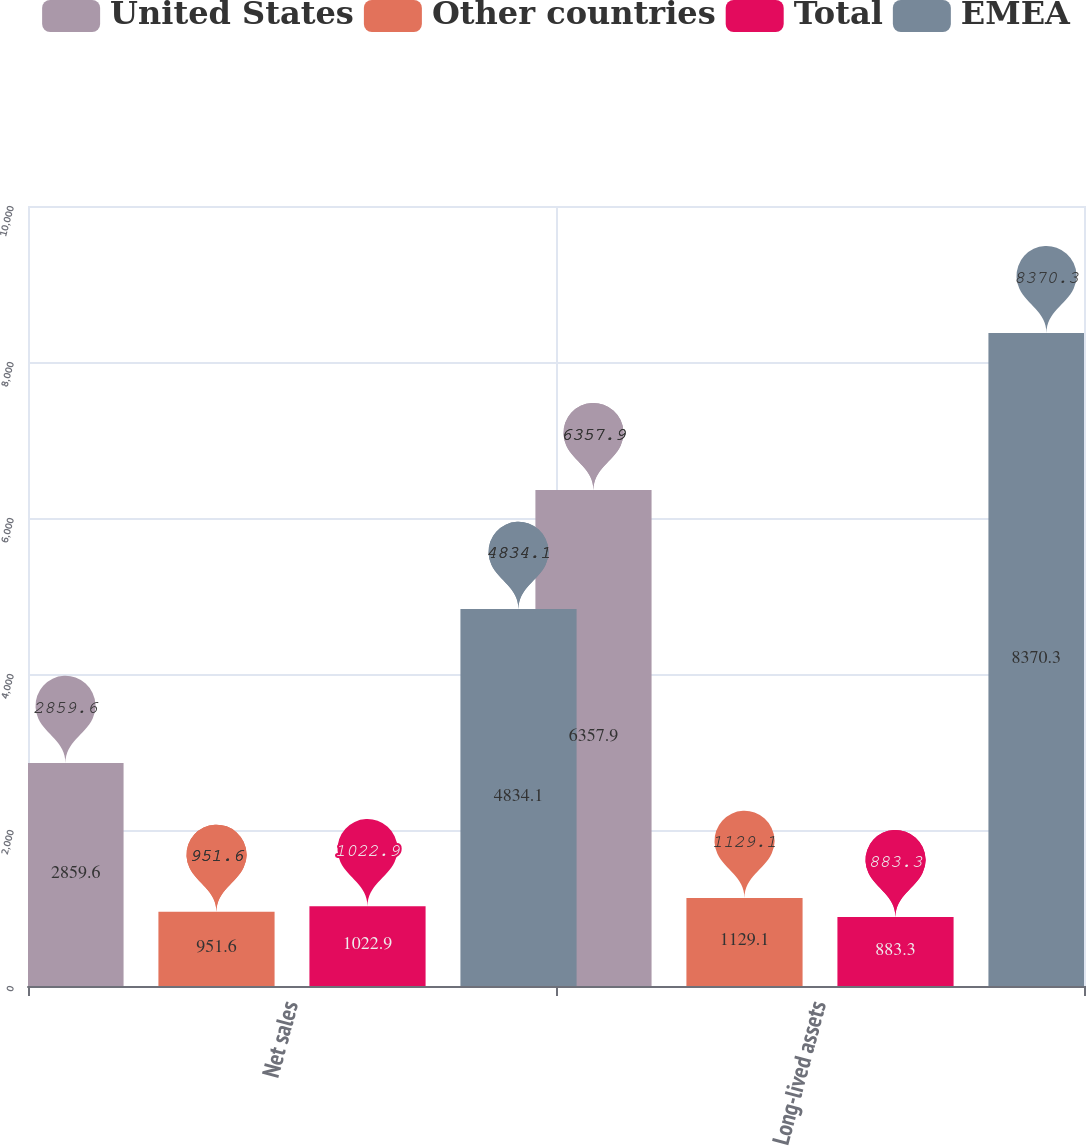<chart> <loc_0><loc_0><loc_500><loc_500><stacked_bar_chart><ecel><fcel>Net sales<fcel>Long-lived assets<nl><fcel>United States<fcel>2859.6<fcel>6357.9<nl><fcel>Other countries<fcel>951.6<fcel>1129.1<nl><fcel>Total<fcel>1022.9<fcel>883.3<nl><fcel>EMEA<fcel>4834.1<fcel>8370.3<nl></chart> 